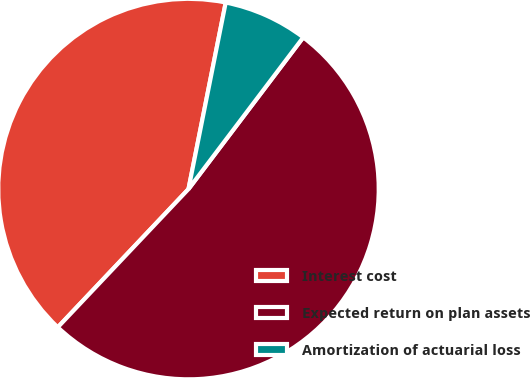Convert chart to OTSL. <chart><loc_0><loc_0><loc_500><loc_500><pie_chart><fcel>Interest cost<fcel>Expected return on plan assets<fcel>Amortization of actuarial loss<nl><fcel>41.08%<fcel>51.75%<fcel>7.17%<nl></chart> 